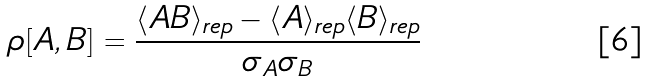<formula> <loc_0><loc_0><loc_500><loc_500>\rho [ A , B ] = \frac { \langle A B \rangle _ { r e p } - \langle A \rangle _ { r e p } \langle B \rangle _ { r e p } } { \sigma _ { A } \sigma _ { B } }</formula> 